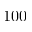<formula> <loc_0><loc_0><loc_500><loc_500>1 0 0</formula> 